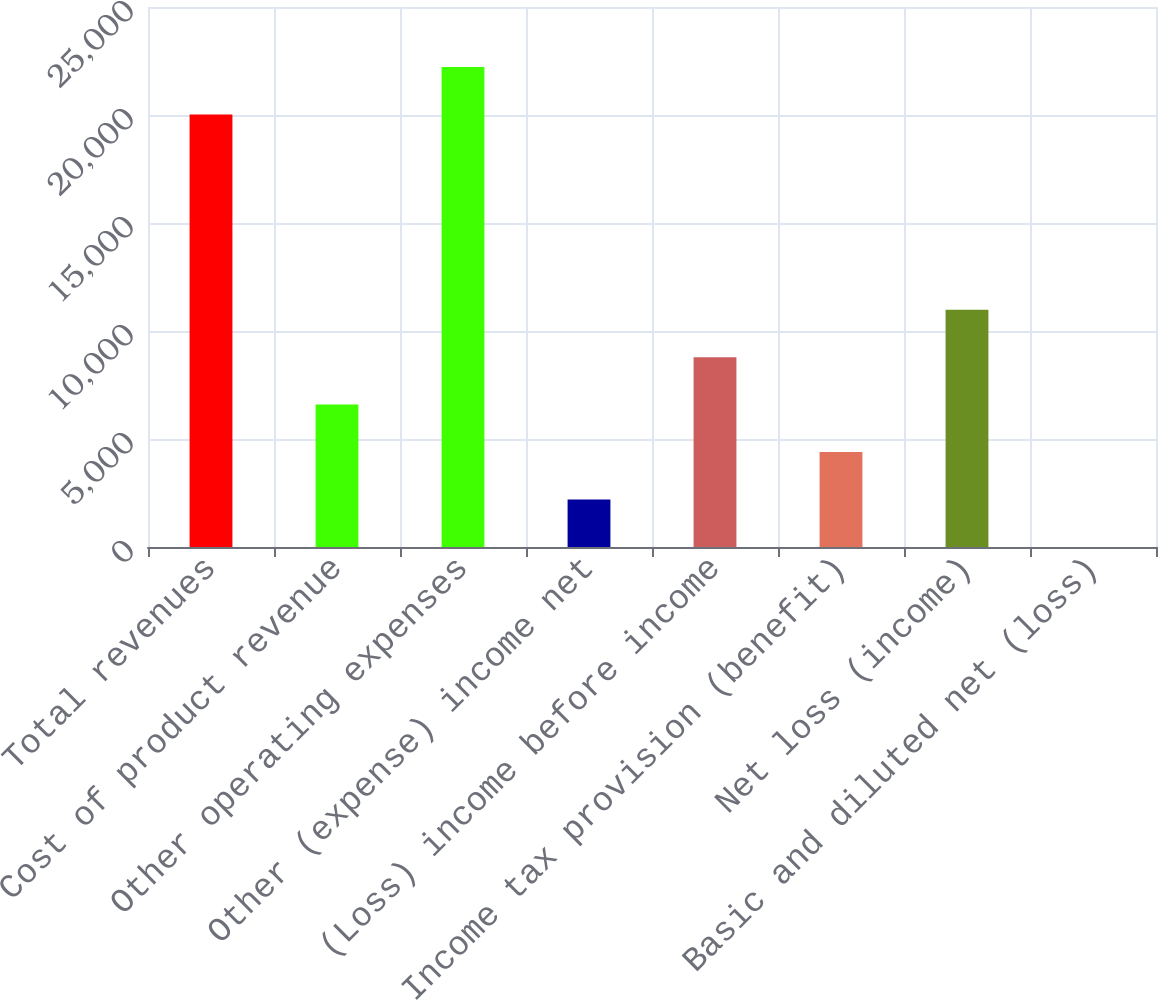<chart> <loc_0><loc_0><loc_500><loc_500><bar_chart><fcel>Total revenues<fcel>Cost of product revenue<fcel>Other operating expenses<fcel>Other (expense) income net<fcel>(Loss) income before income<fcel>Income tax provision (benefit)<fcel>Net loss (income)<fcel>Basic and diluted net (loss)<nl><fcel>20022<fcel>6592.05<fcel>22219.3<fcel>2197.49<fcel>8789.33<fcel>4394.77<fcel>10986.6<fcel>0.21<nl></chart> 